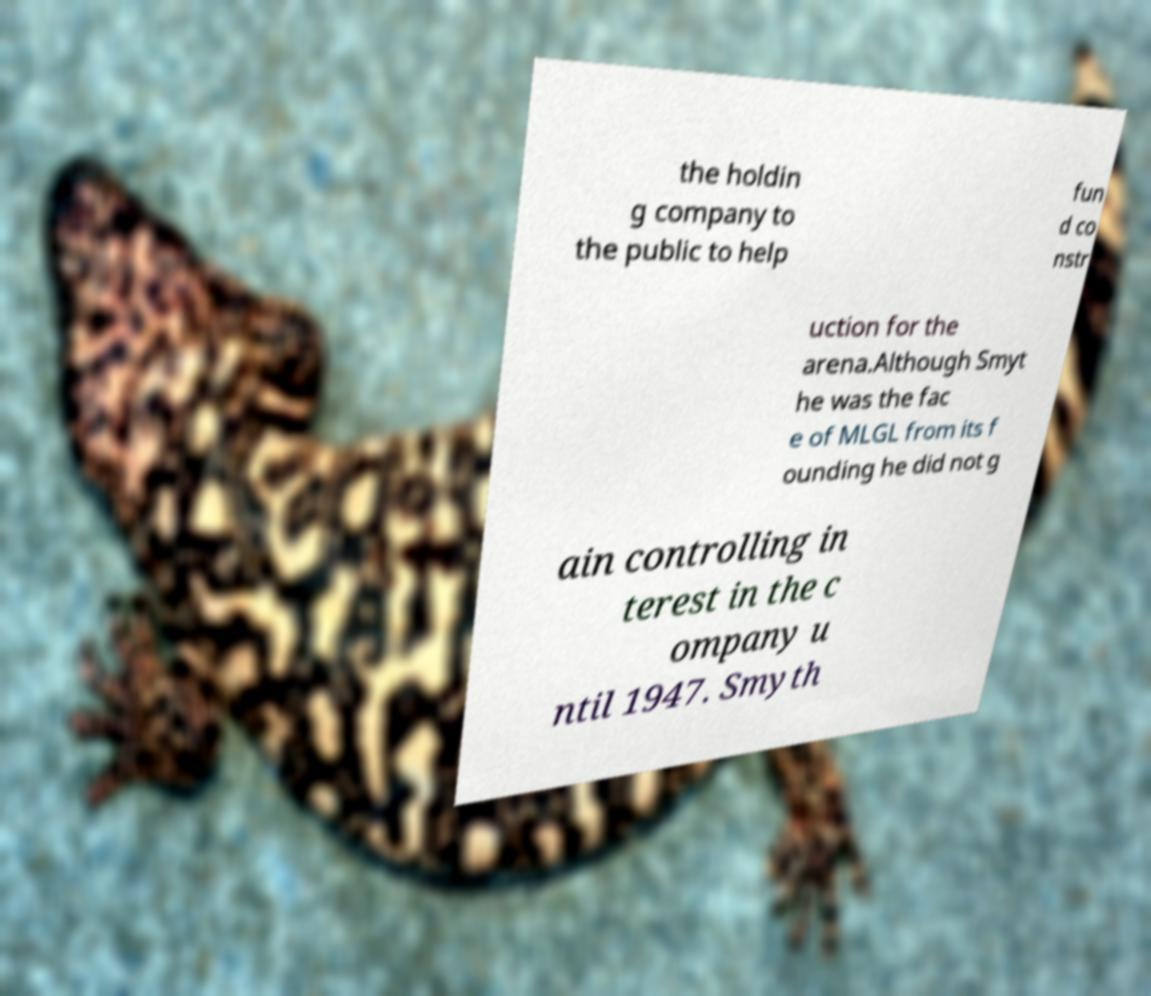Please identify and transcribe the text found in this image. the holdin g company to the public to help fun d co nstr uction for the arena.Although Smyt he was the fac e of MLGL from its f ounding he did not g ain controlling in terest in the c ompany u ntil 1947. Smyth 